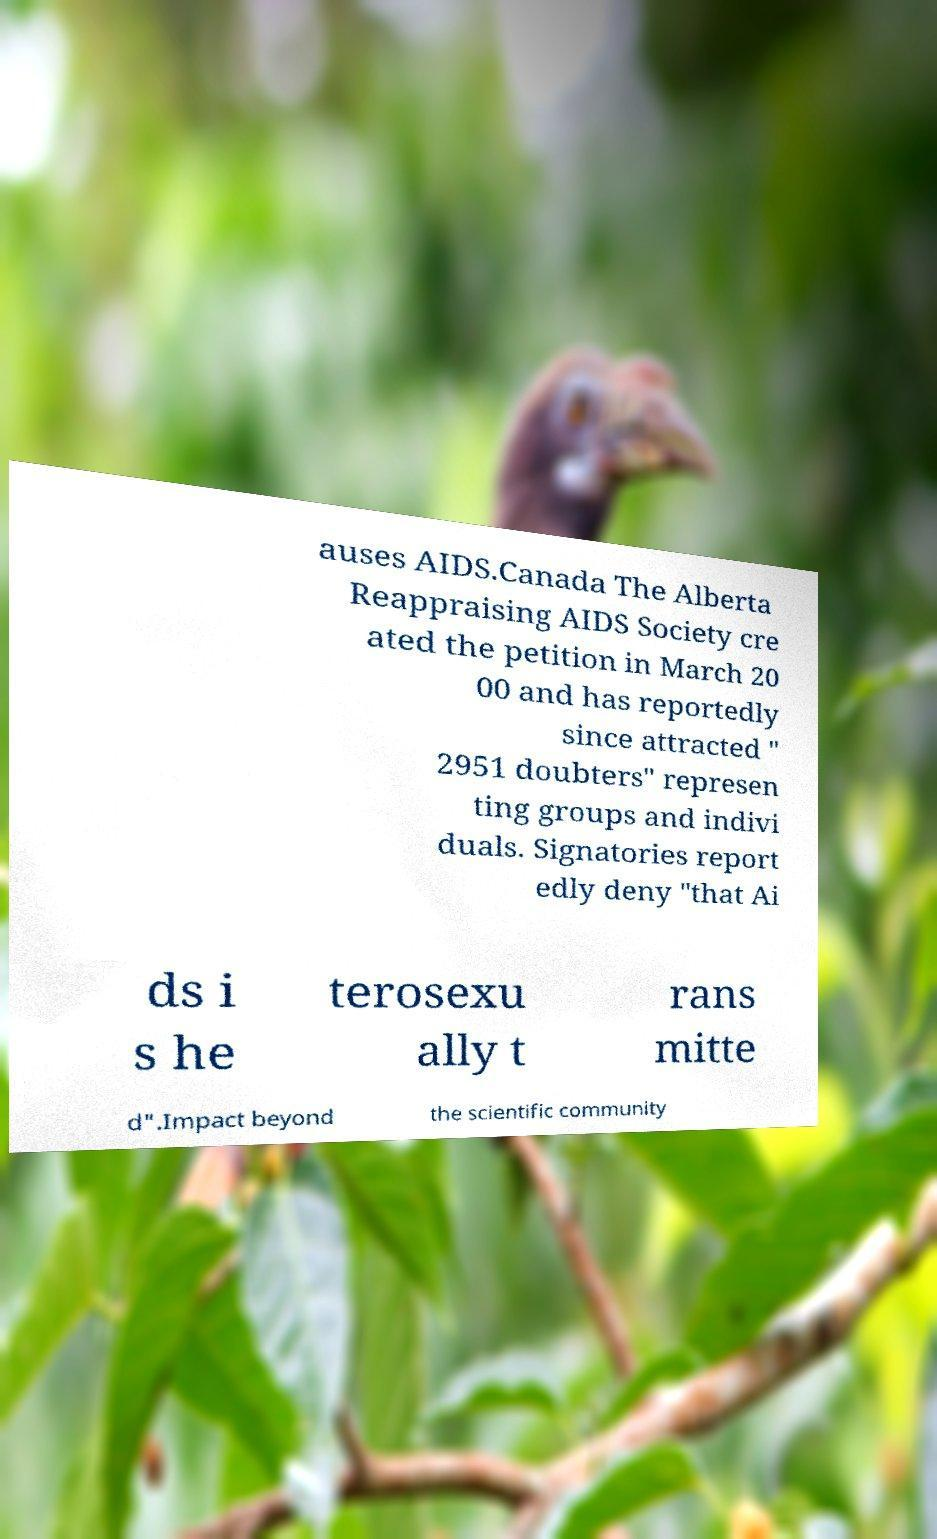What messages or text are displayed in this image? I need them in a readable, typed format. auses AIDS.Canada The Alberta Reappraising AIDS Society cre ated the petition in March 20 00 and has reportedly since attracted " 2951 doubters" represen ting groups and indivi duals. Signatories report edly deny "that Ai ds i s he terosexu ally t rans mitte d".Impact beyond the scientific community 